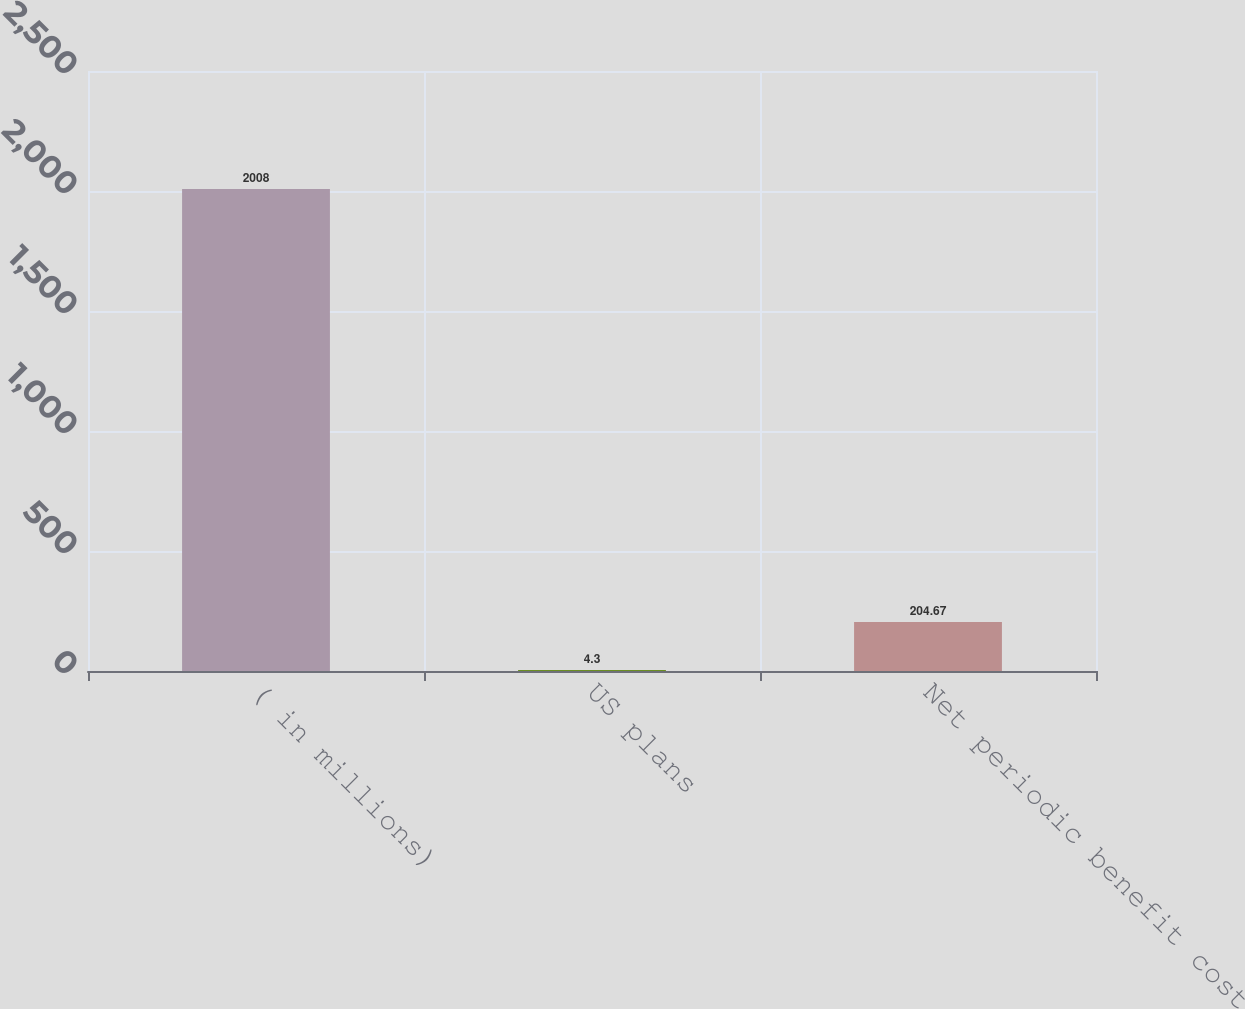<chart> <loc_0><loc_0><loc_500><loc_500><bar_chart><fcel>( in millions)<fcel>US plans<fcel>Net periodic benefit cost<nl><fcel>2008<fcel>4.3<fcel>204.67<nl></chart> 